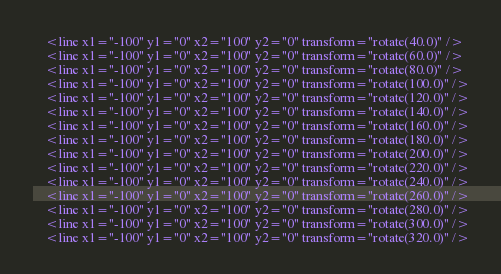Convert code to text. <code><loc_0><loc_0><loc_500><loc_500><_YAML_>    <line x1="-100" y1="0" x2="100" y2="0" transform="rotate(40.0)" />
    <line x1="-100" y1="0" x2="100" y2="0" transform="rotate(60.0)" />
    <line x1="-100" y1="0" x2="100" y2="0" transform="rotate(80.0)" />
    <line x1="-100" y1="0" x2="100" y2="0" transform="rotate(100.0)" />
    <line x1="-100" y1="0" x2="100" y2="0" transform="rotate(120.0)" />
    <line x1="-100" y1="0" x2="100" y2="0" transform="rotate(140.0)" />
    <line x1="-100" y1="0" x2="100" y2="0" transform="rotate(160.0)" />
    <line x1="-100" y1="0" x2="100" y2="0" transform="rotate(180.0)" />
    <line x1="-100" y1="0" x2="100" y2="0" transform="rotate(200.0)" />
    <line x1="-100" y1="0" x2="100" y2="0" transform="rotate(220.0)" />
    <line x1="-100" y1="0" x2="100" y2="0" transform="rotate(240.0)" />
    <line x1="-100" y1="0" x2="100" y2="0" transform="rotate(260.0)" />
    <line x1="-100" y1="0" x2="100" y2="0" transform="rotate(280.0)" />
    <line x1="-100" y1="0" x2="100" y2="0" transform="rotate(300.0)" />
    <line x1="-100" y1="0" x2="100" y2="0" transform="rotate(320.0)" /></code> 